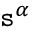<formula> <loc_0><loc_0><loc_500><loc_500>s ^ { \alpha }</formula> 